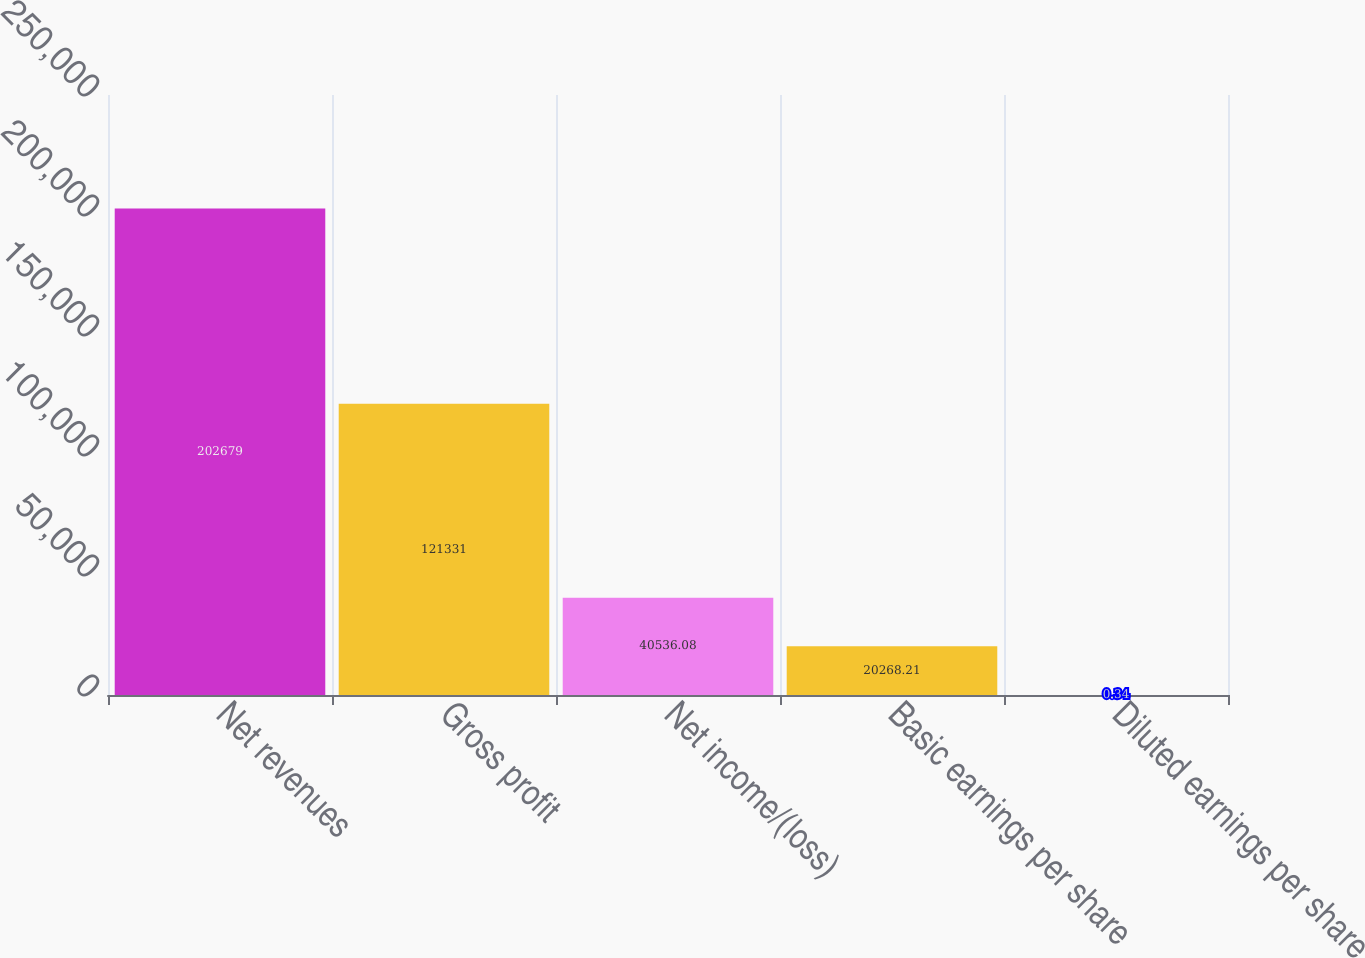<chart> <loc_0><loc_0><loc_500><loc_500><bar_chart><fcel>Net revenues<fcel>Gross profit<fcel>Net income/(loss)<fcel>Basic earnings per share<fcel>Diluted earnings per share<nl><fcel>202679<fcel>121331<fcel>40536.1<fcel>20268.2<fcel>0.34<nl></chart> 